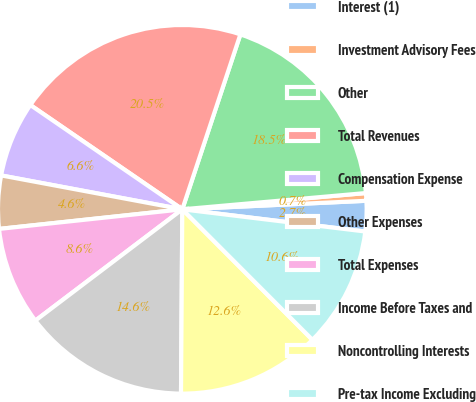Convert chart to OTSL. <chart><loc_0><loc_0><loc_500><loc_500><pie_chart><fcel>Interest (1)<fcel>Investment Advisory Fees<fcel>Other<fcel>Total Revenues<fcel>Compensation Expense<fcel>Other Expenses<fcel>Total Expenses<fcel>Income Before Taxes and<fcel>Noncontrolling Interests<fcel>Pre-tax Income Excluding<nl><fcel>2.66%<fcel>0.67%<fcel>18.49%<fcel>20.53%<fcel>6.63%<fcel>4.64%<fcel>8.62%<fcel>14.57%<fcel>12.59%<fcel>10.6%<nl></chart> 